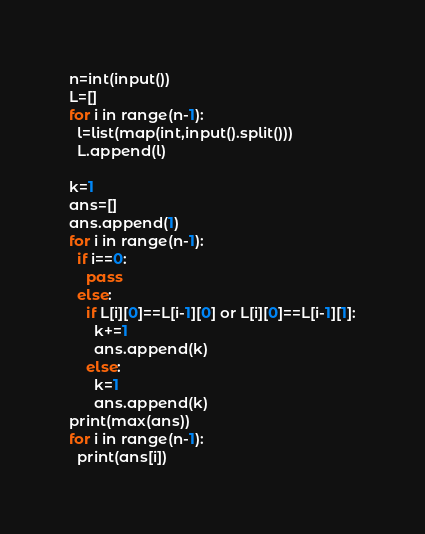Convert code to text. <code><loc_0><loc_0><loc_500><loc_500><_Python_>n=int(input())
L=[]
for i in range(n-1):
  l=list(map(int,input().split()))
  L.append(l)

k=1
ans=[]
ans.append(1)
for i in range(n-1):
  if i==0:
    pass
  else:
    if L[i][0]==L[i-1][0] or L[i][0]==L[i-1][1]:
      k+=1
      ans.append(k)
    else:
      k=1
      ans.append(k)
print(max(ans))
for i in range(n-1):
  print(ans[i])</code> 